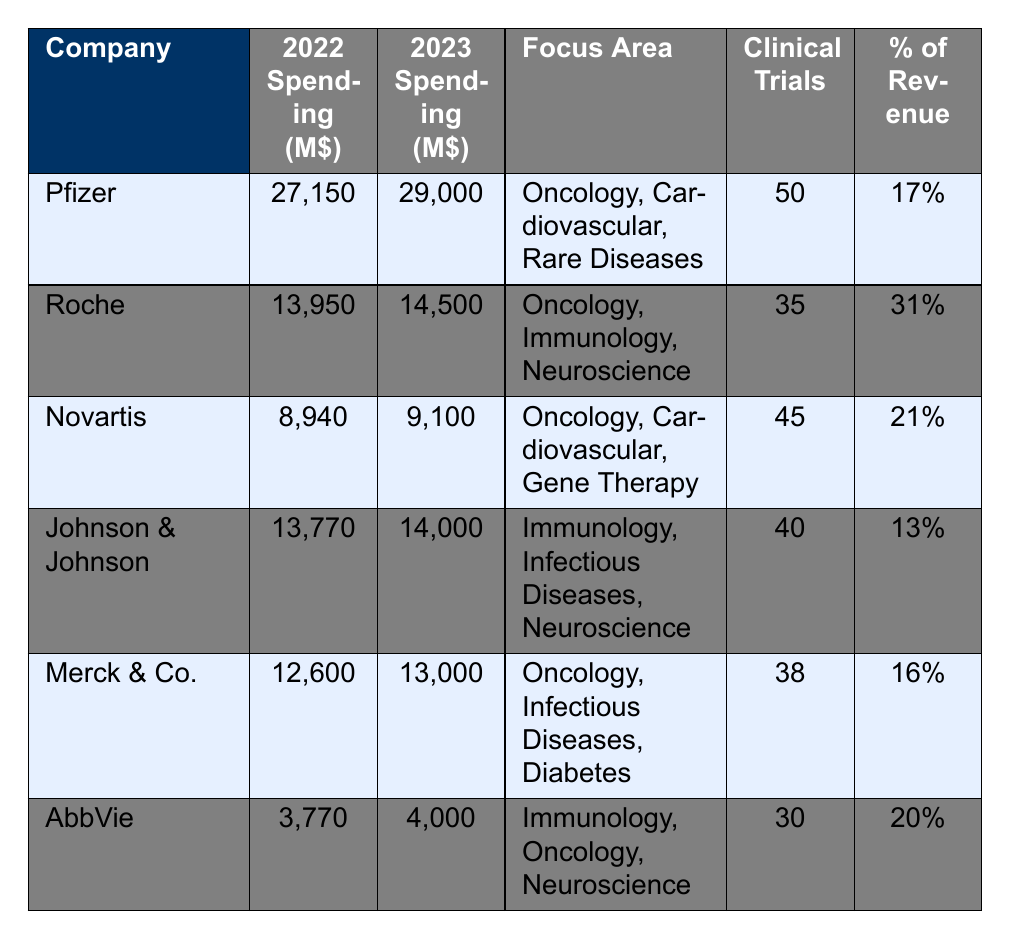What was the R&D spending of Pfizer in 2023? In the table, the R&D spending for Pfizer in 2023 is specified as 29,000 million dollars.
Answer: 29,000 million dollars Which company has the highest percentage of revenue spent on R&D in 2022? The table shows Roche has 31% of its revenue spent on R&D, which is the highest among the listed companies for 2022.
Answer: Roche What is the difference in R&D spending from 2022 to 2023 for Merck & Co.? The spending for Merck & Co. in 2022 is 12,600 million dollars and in 2023 is 13,000 million dollars. The difference is 13,000 - 12,600 = 400 million dollars.
Answer: 400 million dollars How many clinical trials did Novartis conduct compared to AbbVie? Novartis conducted 45 clinical trials while AbbVie conducted 30 trials. The difference is 45 - 30 = 15 trials, meaning Novartis conducted 15 more trials than AbbVie.
Answer: 15 trials Which company increased their R&D spending by the largest amount from 2022 to 2023? Evaluating each company's spending increase: Pfizer (1,850), Roche (550), Novartis (160), Johnson & Johnson (230), Merck & Co. (400), and AbbVie (230). Pfizer’s increase of 1,850 million dollars is the largest.
Answer: Pfizer What is the average R&D spending across all companies for 2023? To calculate the average, sum all 2023 spending amounts: 29,000 + 14,500 + 9,100 + 14,000 + 13,000 + 4,000 = 83,600 million dollars. There are 6 companies, so the average is 83,600 / 6 = 13,933.33 million dollars.
Answer: 13,933.33 million dollars Is AbbVie focusing on oncology in their R&D? The table states that AbbVie’s focus area includes immunology, oncology, and neuroscience, which confirms they are indeed focusing on oncology.
Answer: Yes Which company has the least amount of R&D spending in 2022? The table shows AbbVie with 3,770 million dollars spent on R&D in 2022, which is the lowest among all listed companies.
Answer: AbbVie 